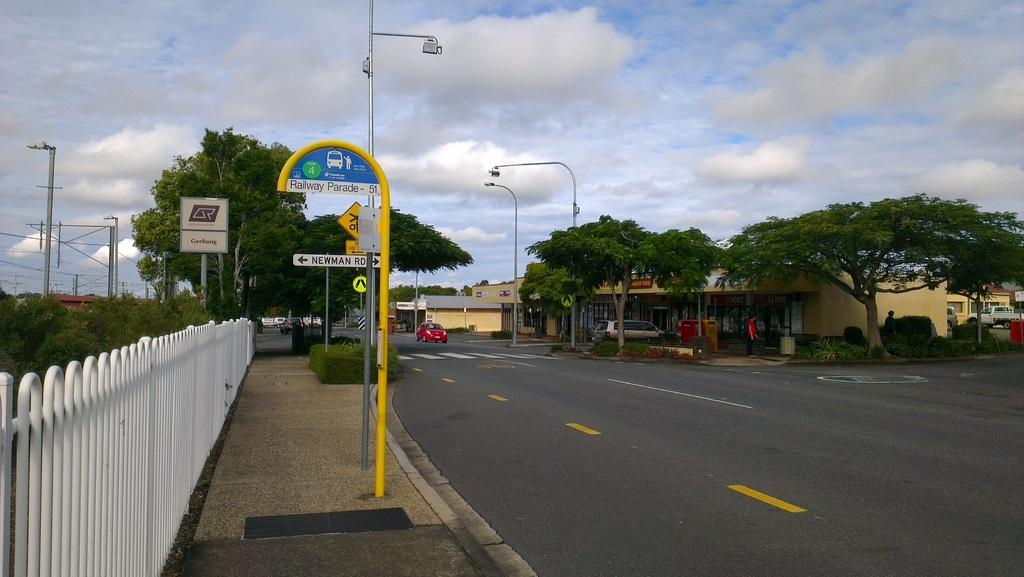<image>
Offer a succinct explanation of the picture presented. An empty street with a sign on a yellow pole that reads Railway Parade 51. 